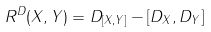<formula> <loc_0><loc_0><loc_500><loc_500>R ^ { D } ( X , Y ) = D _ { [ X , Y ] } - [ D _ { X } , D _ { Y } ]</formula> 